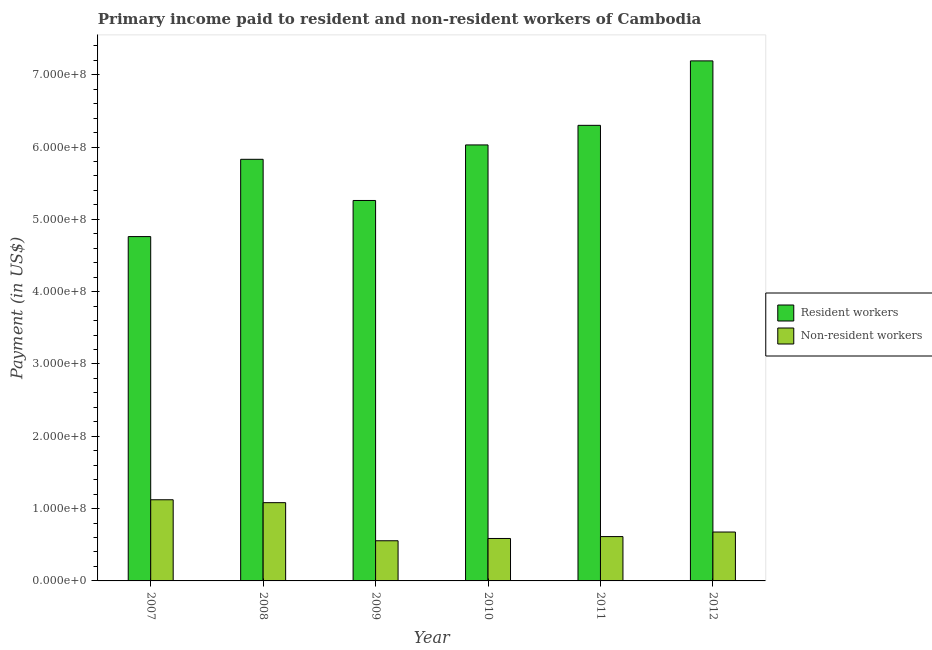How many different coloured bars are there?
Offer a terse response. 2. Are the number of bars per tick equal to the number of legend labels?
Ensure brevity in your answer.  Yes. Are the number of bars on each tick of the X-axis equal?
Keep it short and to the point. Yes. How many bars are there on the 5th tick from the left?
Offer a very short reply. 2. What is the label of the 3rd group of bars from the left?
Your answer should be compact. 2009. In how many cases, is the number of bars for a given year not equal to the number of legend labels?
Make the answer very short. 0. What is the payment made to non-resident workers in 2011?
Ensure brevity in your answer.  6.13e+07. Across all years, what is the maximum payment made to resident workers?
Offer a very short reply. 7.19e+08. Across all years, what is the minimum payment made to non-resident workers?
Offer a terse response. 5.55e+07. In which year was the payment made to non-resident workers maximum?
Provide a succinct answer. 2007. In which year was the payment made to non-resident workers minimum?
Offer a very short reply. 2009. What is the total payment made to resident workers in the graph?
Ensure brevity in your answer.  3.54e+09. What is the difference between the payment made to resident workers in 2009 and that in 2011?
Offer a very short reply. -1.04e+08. What is the difference between the payment made to non-resident workers in 2011 and the payment made to resident workers in 2010?
Offer a terse response. 2.62e+06. What is the average payment made to non-resident workers per year?
Keep it short and to the point. 7.73e+07. In how many years, is the payment made to resident workers greater than 520000000 US$?
Keep it short and to the point. 5. What is the ratio of the payment made to resident workers in 2010 to that in 2012?
Provide a short and direct response. 0.84. What is the difference between the highest and the second highest payment made to resident workers?
Your response must be concise. 8.91e+07. What is the difference between the highest and the lowest payment made to non-resident workers?
Give a very brief answer. 5.67e+07. In how many years, is the payment made to non-resident workers greater than the average payment made to non-resident workers taken over all years?
Keep it short and to the point. 2. Is the sum of the payment made to resident workers in 2008 and 2010 greater than the maximum payment made to non-resident workers across all years?
Provide a short and direct response. Yes. What does the 1st bar from the left in 2008 represents?
Offer a very short reply. Resident workers. What does the 1st bar from the right in 2007 represents?
Ensure brevity in your answer.  Non-resident workers. How many bars are there?
Offer a very short reply. 12. What is the difference between two consecutive major ticks on the Y-axis?
Offer a very short reply. 1.00e+08. Are the values on the major ticks of Y-axis written in scientific E-notation?
Provide a short and direct response. Yes. Does the graph contain any zero values?
Provide a succinct answer. No. Does the graph contain grids?
Your answer should be compact. No. Where does the legend appear in the graph?
Your answer should be very brief. Center right. What is the title of the graph?
Your answer should be compact. Primary income paid to resident and non-resident workers of Cambodia. Does "% of GNI" appear as one of the legend labels in the graph?
Your answer should be compact. No. What is the label or title of the Y-axis?
Give a very brief answer. Payment (in US$). What is the Payment (in US$) of Resident workers in 2007?
Provide a short and direct response. 4.76e+08. What is the Payment (in US$) of Non-resident workers in 2007?
Make the answer very short. 1.12e+08. What is the Payment (in US$) in Resident workers in 2008?
Offer a terse response. 5.83e+08. What is the Payment (in US$) of Non-resident workers in 2008?
Make the answer very short. 1.08e+08. What is the Payment (in US$) of Resident workers in 2009?
Your response must be concise. 5.26e+08. What is the Payment (in US$) of Non-resident workers in 2009?
Your answer should be very brief. 5.55e+07. What is the Payment (in US$) in Resident workers in 2010?
Your answer should be compact. 6.03e+08. What is the Payment (in US$) of Non-resident workers in 2010?
Your answer should be compact. 5.87e+07. What is the Payment (in US$) in Resident workers in 2011?
Your answer should be very brief. 6.30e+08. What is the Payment (in US$) in Non-resident workers in 2011?
Give a very brief answer. 6.13e+07. What is the Payment (in US$) in Resident workers in 2012?
Keep it short and to the point. 7.19e+08. What is the Payment (in US$) of Non-resident workers in 2012?
Provide a short and direct response. 6.76e+07. Across all years, what is the maximum Payment (in US$) of Resident workers?
Ensure brevity in your answer.  7.19e+08. Across all years, what is the maximum Payment (in US$) of Non-resident workers?
Your response must be concise. 1.12e+08. Across all years, what is the minimum Payment (in US$) of Resident workers?
Provide a succinct answer. 4.76e+08. Across all years, what is the minimum Payment (in US$) of Non-resident workers?
Your answer should be compact. 5.55e+07. What is the total Payment (in US$) of Resident workers in the graph?
Provide a succinct answer. 3.54e+09. What is the total Payment (in US$) in Non-resident workers in the graph?
Your answer should be very brief. 4.64e+08. What is the difference between the Payment (in US$) in Resident workers in 2007 and that in 2008?
Provide a succinct answer. -1.07e+08. What is the difference between the Payment (in US$) of Non-resident workers in 2007 and that in 2008?
Provide a short and direct response. 4.02e+06. What is the difference between the Payment (in US$) in Resident workers in 2007 and that in 2009?
Keep it short and to the point. -4.99e+07. What is the difference between the Payment (in US$) in Non-resident workers in 2007 and that in 2009?
Your answer should be very brief. 5.67e+07. What is the difference between the Payment (in US$) in Resident workers in 2007 and that in 2010?
Offer a terse response. -1.27e+08. What is the difference between the Payment (in US$) of Non-resident workers in 2007 and that in 2010?
Offer a terse response. 5.35e+07. What is the difference between the Payment (in US$) of Resident workers in 2007 and that in 2011?
Provide a succinct answer. -1.54e+08. What is the difference between the Payment (in US$) of Non-resident workers in 2007 and that in 2011?
Provide a short and direct response. 5.09e+07. What is the difference between the Payment (in US$) in Resident workers in 2007 and that in 2012?
Keep it short and to the point. -2.43e+08. What is the difference between the Payment (in US$) in Non-resident workers in 2007 and that in 2012?
Keep it short and to the point. 4.46e+07. What is the difference between the Payment (in US$) of Resident workers in 2008 and that in 2009?
Keep it short and to the point. 5.69e+07. What is the difference between the Payment (in US$) in Non-resident workers in 2008 and that in 2009?
Your answer should be compact. 5.27e+07. What is the difference between the Payment (in US$) of Resident workers in 2008 and that in 2010?
Give a very brief answer. -1.99e+07. What is the difference between the Payment (in US$) in Non-resident workers in 2008 and that in 2010?
Give a very brief answer. 4.95e+07. What is the difference between the Payment (in US$) of Resident workers in 2008 and that in 2011?
Offer a very short reply. -4.70e+07. What is the difference between the Payment (in US$) of Non-resident workers in 2008 and that in 2011?
Keep it short and to the point. 4.69e+07. What is the difference between the Payment (in US$) of Resident workers in 2008 and that in 2012?
Keep it short and to the point. -1.36e+08. What is the difference between the Payment (in US$) in Non-resident workers in 2008 and that in 2012?
Ensure brevity in your answer.  4.06e+07. What is the difference between the Payment (in US$) in Resident workers in 2009 and that in 2010?
Ensure brevity in your answer.  -7.68e+07. What is the difference between the Payment (in US$) of Non-resident workers in 2009 and that in 2010?
Offer a terse response. -3.15e+06. What is the difference between the Payment (in US$) of Resident workers in 2009 and that in 2011?
Offer a very short reply. -1.04e+08. What is the difference between the Payment (in US$) in Non-resident workers in 2009 and that in 2011?
Your answer should be very brief. -5.77e+06. What is the difference between the Payment (in US$) in Resident workers in 2009 and that in 2012?
Your answer should be compact. -1.93e+08. What is the difference between the Payment (in US$) in Non-resident workers in 2009 and that in 2012?
Provide a succinct answer. -1.21e+07. What is the difference between the Payment (in US$) of Resident workers in 2010 and that in 2011?
Give a very brief answer. -2.71e+07. What is the difference between the Payment (in US$) of Non-resident workers in 2010 and that in 2011?
Your answer should be very brief. -2.62e+06. What is the difference between the Payment (in US$) in Resident workers in 2010 and that in 2012?
Make the answer very short. -1.16e+08. What is the difference between the Payment (in US$) of Non-resident workers in 2010 and that in 2012?
Your answer should be very brief. -8.93e+06. What is the difference between the Payment (in US$) in Resident workers in 2011 and that in 2012?
Offer a very short reply. -8.91e+07. What is the difference between the Payment (in US$) of Non-resident workers in 2011 and that in 2012?
Give a very brief answer. -6.31e+06. What is the difference between the Payment (in US$) of Resident workers in 2007 and the Payment (in US$) of Non-resident workers in 2008?
Offer a very short reply. 3.68e+08. What is the difference between the Payment (in US$) in Resident workers in 2007 and the Payment (in US$) in Non-resident workers in 2009?
Offer a very short reply. 4.21e+08. What is the difference between the Payment (in US$) in Resident workers in 2007 and the Payment (in US$) in Non-resident workers in 2010?
Make the answer very short. 4.17e+08. What is the difference between the Payment (in US$) in Resident workers in 2007 and the Payment (in US$) in Non-resident workers in 2011?
Your answer should be very brief. 4.15e+08. What is the difference between the Payment (in US$) in Resident workers in 2007 and the Payment (in US$) in Non-resident workers in 2012?
Offer a terse response. 4.09e+08. What is the difference between the Payment (in US$) in Resident workers in 2008 and the Payment (in US$) in Non-resident workers in 2009?
Offer a very short reply. 5.27e+08. What is the difference between the Payment (in US$) of Resident workers in 2008 and the Payment (in US$) of Non-resident workers in 2010?
Offer a terse response. 5.24e+08. What is the difference between the Payment (in US$) in Resident workers in 2008 and the Payment (in US$) in Non-resident workers in 2011?
Provide a short and direct response. 5.22e+08. What is the difference between the Payment (in US$) of Resident workers in 2008 and the Payment (in US$) of Non-resident workers in 2012?
Provide a succinct answer. 5.15e+08. What is the difference between the Payment (in US$) in Resident workers in 2009 and the Payment (in US$) in Non-resident workers in 2010?
Provide a succinct answer. 4.67e+08. What is the difference between the Payment (in US$) of Resident workers in 2009 and the Payment (in US$) of Non-resident workers in 2011?
Offer a terse response. 4.65e+08. What is the difference between the Payment (in US$) of Resident workers in 2009 and the Payment (in US$) of Non-resident workers in 2012?
Make the answer very short. 4.58e+08. What is the difference between the Payment (in US$) in Resident workers in 2010 and the Payment (in US$) in Non-resident workers in 2011?
Keep it short and to the point. 5.42e+08. What is the difference between the Payment (in US$) of Resident workers in 2010 and the Payment (in US$) of Non-resident workers in 2012?
Your response must be concise. 5.35e+08. What is the difference between the Payment (in US$) in Resident workers in 2011 and the Payment (in US$) in Non-resident workers in 2012?
Give a very brief answer. 5.62e+08. What is the average Payment (in US$) of Resident workers per year?
Provide a succinct answer. 5.90e+08. What is the average Payment (in US$) in Non-resident workers per year?
Keep it short and to the point. 7.73e+07. In the year 2007, what is the difference between the Payment (in US$) in Resident workers and Payment (in US$) in Non-resident workers?
Provide a short and direct response. 3.64e+08. In the year 2008, what is the difference between the Payment (in US$) in Resident workers and Payment (in US$) in Non-resident workers?
Keep it short and to the point. 4.75e+08. In the year 2009, what is the difference between the Payment (in US$) of Resident workers and Payment (in US$) of Non-resident workers?
Offer a terse response. 4.71e+08. In the year 2010, what is the difference between the Payment (in US$) of Resident workers and Payment (in US$) of Non-resident workers?
Your answer should be compact. 5.44e+08. In the year 2011, what is the difference between the Payment (in US$) in Resident workers and Payment (in US$) in Non-resident workers?
Provide a short and direct response. 5.69e+08. In the year 2012, what is the difference between the Payment (in US$) of Resident workers and Payment (in US$) of Non-resident workers?
Your response must be concise. 6.52e+08. What is the ratio of the Payment (in US$) of Resident workers in 2007 to that in 2008?
Your answer should be very brief. 0.82. What is the ratio of the Payment (in US$) of Non-resident workers in 2007 to that in 2008?
Provide a succinct answer. 1.04. What is the ratio of the Payment (in US$) in Resident workers in 2007 to that in 2009?
Provide a succinct answer. 0.91. What is the ratio of the Payment (in US$) of Non-resident workers in 2007 to that in 2009?
Make the answer very short. 2.02. What is the ratio of the Payment (in US$) of Resident workers in 2007 to that in 2010?
Your answer should be compact. 0.79. What is the ratio of the Payment (in US$) in Non-resident workers in 2007 to that in 2010?
Provide a short and direct response. 1.91. What is the ratio of the Payment (in US$) in Resident workers in 2007 to that in 2011?
Your response must be concise. 0.76. What is the ratio of the Payment (in US$) in Non-resident workers in 2007 to that in 2011?
Keep it short and to the point. 1.83. What is the ratio of the Payment (in US$) in Resident workers in 2007 to that in 2012?
Give a very brief answer. 0.66. What is the ratio of the Payment (in US$) of Non-resident workers in 2007 to that in 2012?
Make the answer very short. 1.66. What is the ratio of the Payment (in US$) of Resident workers in 2008 to that in 2009?
Provide a succinct answer. 1.11. What is the ratio of the Payment (in US$) of Non-resident workers in 2008 to that in 2009?
Offer a very short reply. 1.95. What is the ratio of the Payment (in US$) of Non-resident workers in 2008 to that in 2010?
Your response must be concise. 1.84. What is the ratio of the Payment (in US$) in Resident workers in 2008 to that in 2011?
Offer a terse response. 0.93. What is the ratio of the Payment (in US$) in Non-resident workers in 2008 to that in 2011?
Ensure brevity in your answer.  1.76. What is the ratio of the Payment (in US$) of Resident workers in 2008 to that in 2012?
Provide a succinct answer. 0.81. What is the ratio of the Payment (in US$) in Non-resident workers in 2008 to that in 2012?
Give a very brief answer. 1.6. What is the ratio of the Payment (in US$) in Resident workers in 2009 to that in 2010?
Make the answer very short. 0.87. What is the ratio of the Payment (in US$) of Non-resident workers in 2009 to that in 2010?
Provide a short and direct response. 0.95. What is the ratio of the Payment (in US$) of Resident workers in 2009 to that in 2011?
Offer a terse response. 0.84. What is the ratio of the Payment (in US$) in Non-resident workers in 2009 to that in 2011?
Provide a short and direct response. 0.91. What is the ratio of the Payment (in US$) in Resident workers in 2009 to that in 2012?
Your response must be concise. 0.73. What is the ratio of the Payment (in US$) of Non-resident workers in 2009 to that in 2012?
Offer a very short reply. 0.82. What is the ratio of the Payment (in US$) in Resident workers in 2010 to that in 2011?
Make the answer very short. 0.96. What is the ratio of the Payment (in US$) of Non-resident workers in 2010 to that in 2011?
Offer a terse response. 0.96. What is the ratio of the Payment (in US$) in Resident workers in 2010 to that in 2012?
Keep it short and to the point. 0.84. What is the ratio of the Payment (in US$) of Non-resident workers in 2010 to that in 2012?
Give a very brief answer. 0.87. What is the ratio of the Payment (in US$) in Resident workers in 2011 to that in 2012?
Provide a short and direct response. 0.88. What is the ratio of the Payment (in US$) of Non-resident workers in 2011 to that in 2012?
Your response must be concise. 0.91. What is the difference between the highest and the second highest Payment (in US$) in Resident workers?
Your response must be concise. 8.91e+07. What is the difference between the highest and the second highest Payment (in US$) in Non-resident workers?
Give a very brief answer. 4.02e+06. What is the difference between the highest and the lowest Payment (in US$) in Resident workers?
Provide a short and direct response. 2.43e+08. What is the difference between the highest and the lowest Payment (in US$) of Non-resident workers?
Ensure brevity in your answer.  5.67e+07. 